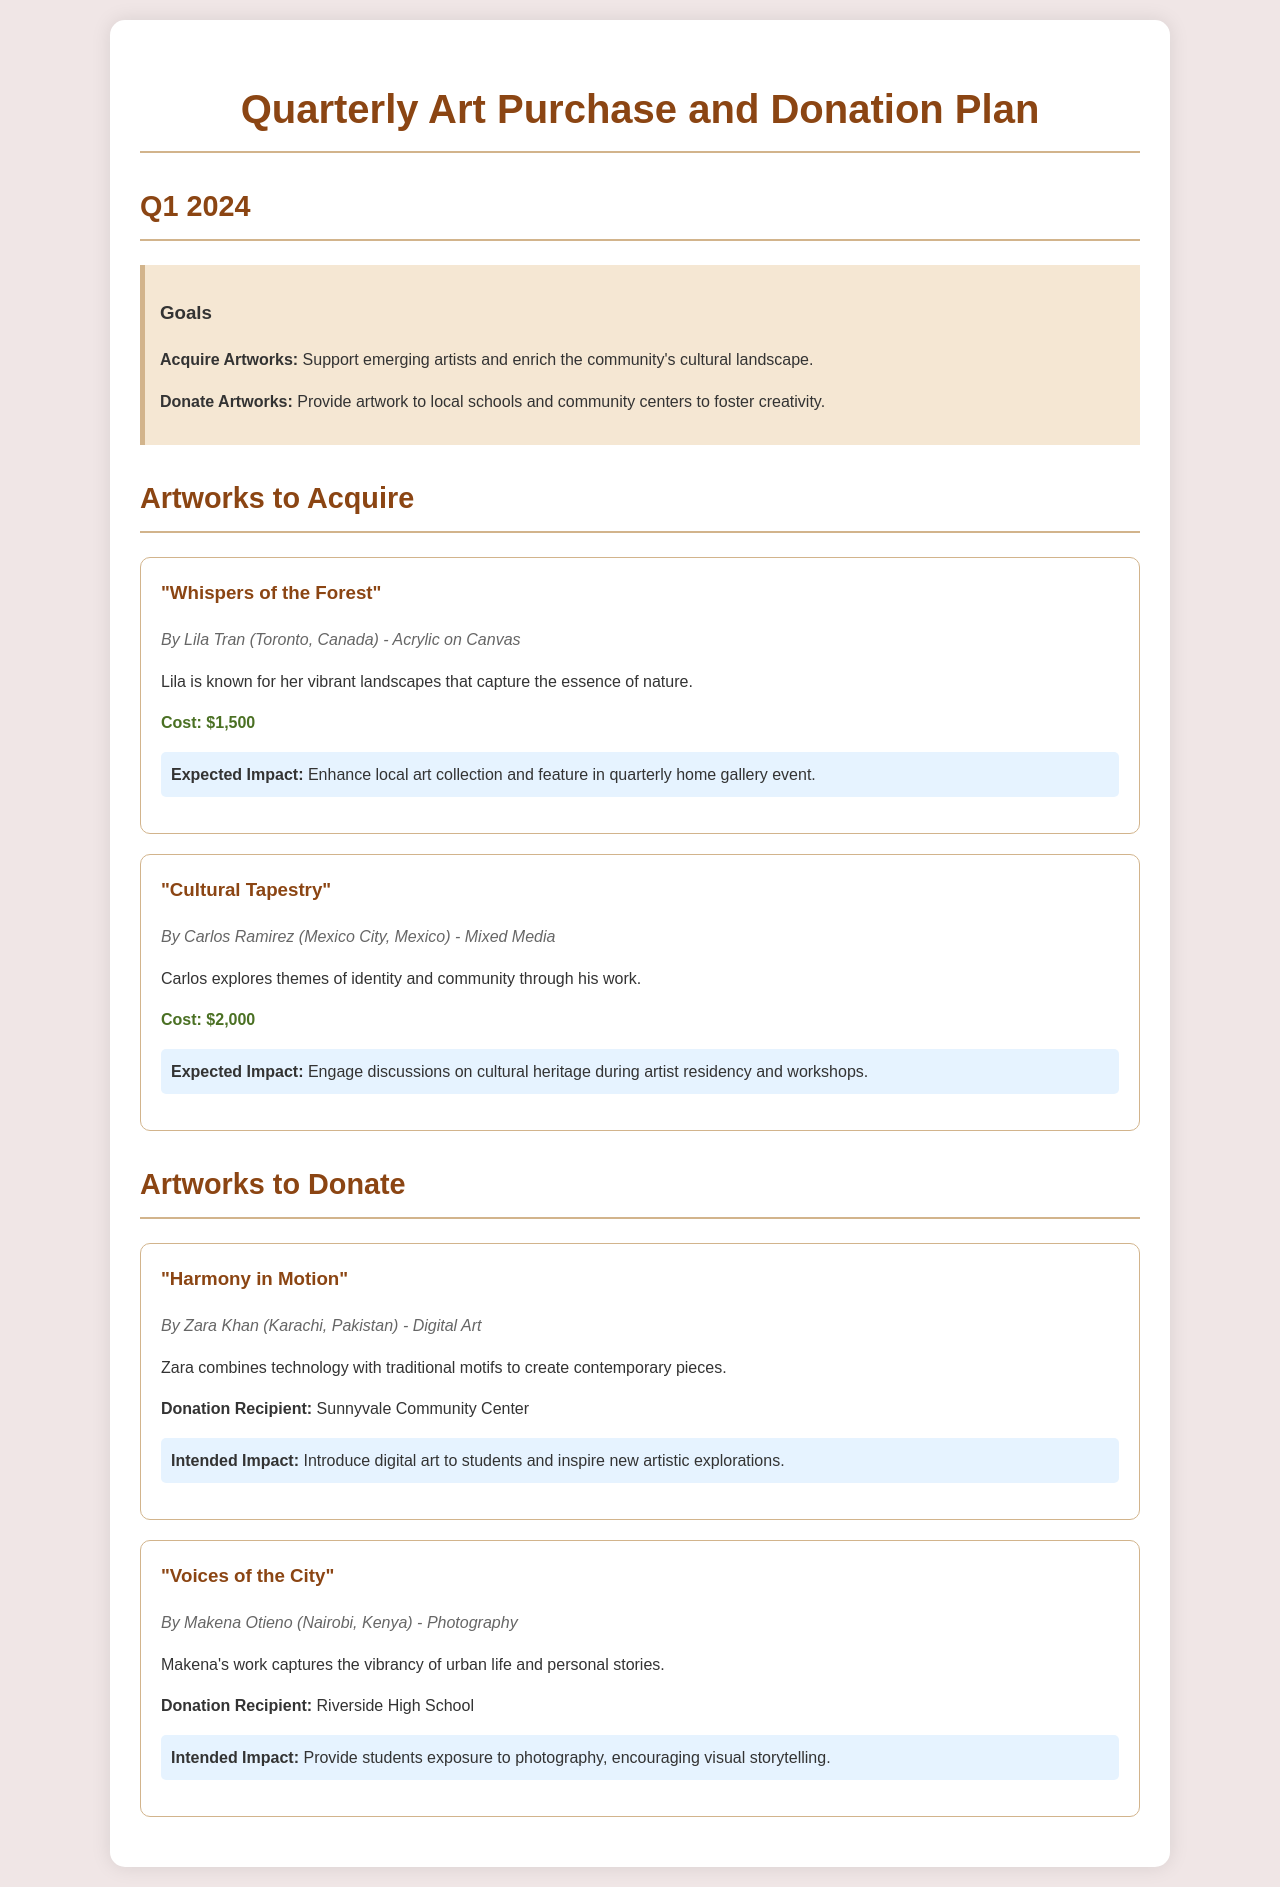What is the title of the first artwork to acquire? The title is listed in the document under "Artworks to Acquire," which is "Whispers of the Forest."
Answer: Whispers of the Forest Who is the artist of "Cultural Tapestry"? The artist's name is mentioned with the artwork's details, which is Carlos Ramirez.
Answer: Carlos Ramirez What is the cost of "Harmony in Motion"? The cost of the artwork is specified in the donation section; however, the specific figure is not stated here. It is titled "Harmony in Motion," and its cost does not appear in the donation section.
Answer: Not mentioned Which community center will receive "Harmony in Motion"? The recipient of the artwork donation is outlined in the document. It is set for Sunnyvale Community Center.
Answer: Sunnyvale Community Center What medium does Lila Tran use for her artwork? The medium is provided in the artist and artwork description, which states it is Acrylic on Canvas.
Answer: Acrylic on Canvas What is the expected impact of "Cultural Tapestry"? The intended outcome is summarized in the impact description related to discussions on cultural heritage during artist residency and workshops.
Answer: Engage discussions on cultural heritage Who created "Voices of the City"? The artist for this photography piece is clearly identified in the document, which is Makena Otieno.
Answer: Makena Otieno What is the intended impact of donating "Voices of the City"? The impact description emphasizes providing exposure to photography and encouraging visual storytelling for students.
Answer: Encourage visual storytelling 